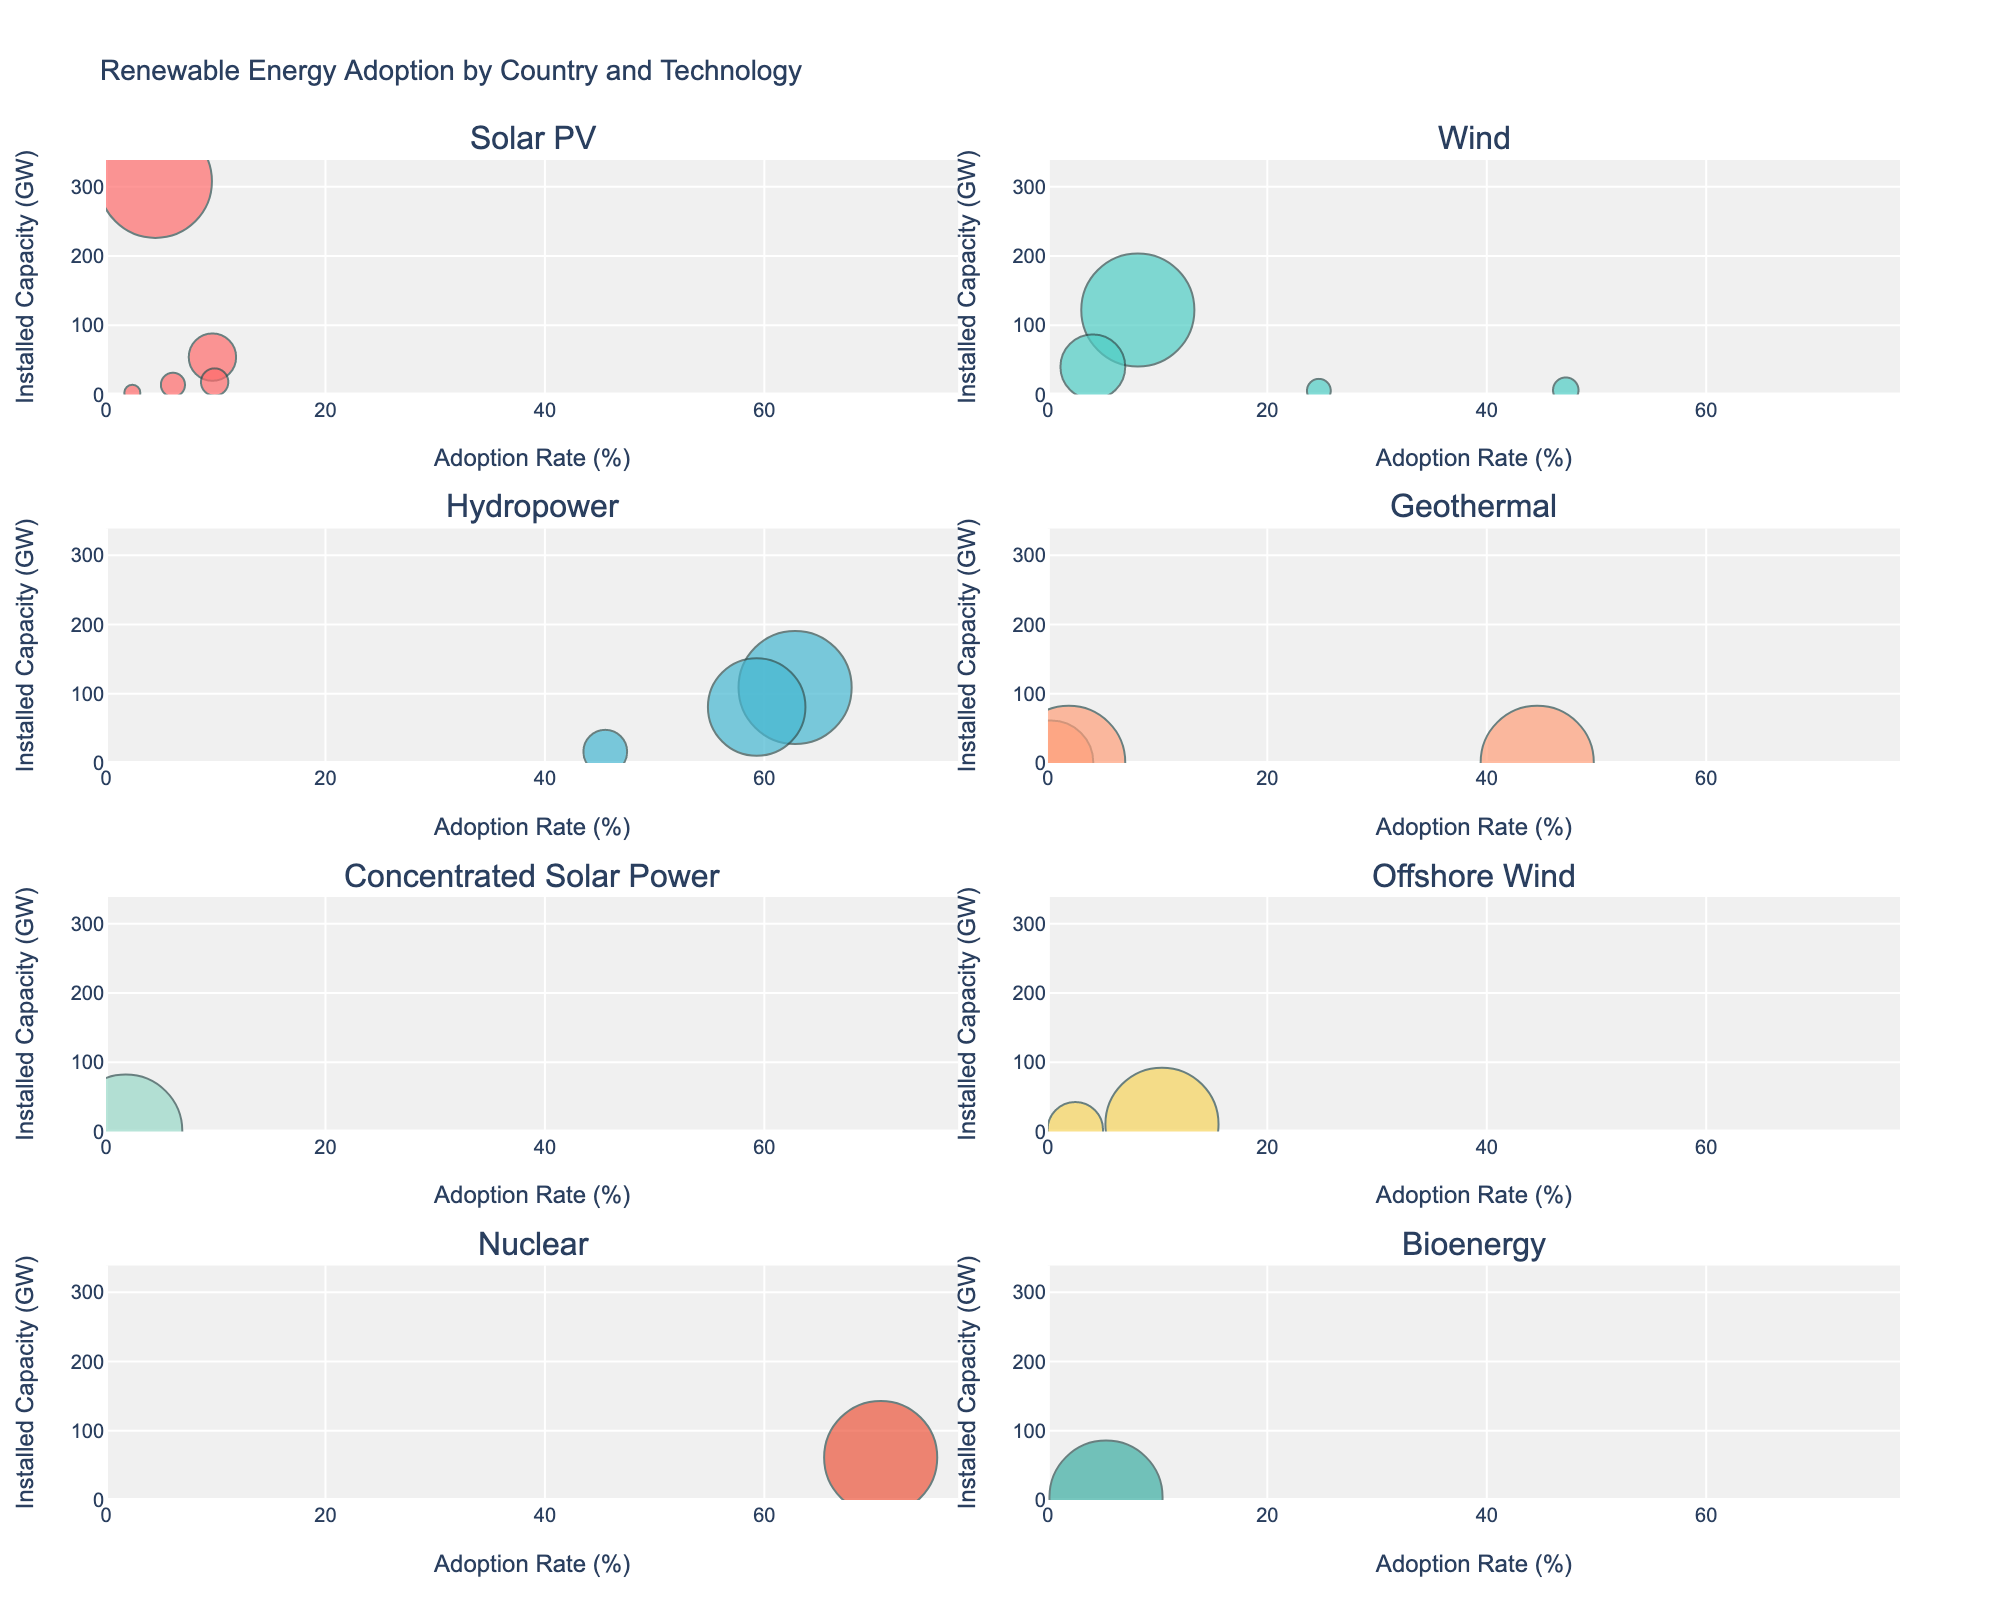Which technology type has the highest adoption rate? The adoption rate is displayed along the x-axis. By scanning the x-axis, we see that France's Nuclear technology has the highest value of 70.6%.
Answer: Nuclear What is the installed capacity of Solar PV in China? Find the bubble chart for Solar PV and locate the bubble representing China. The y-axis indicates the installed capacity, which is 308 GW for China.
Answer: 308 GW How many countries have an adoption rate higher than 40%? By observing the x-axes across different subplots, count the bubbles whose x-values exceed 40%. This occurs for Hydropower in Brazil and Canada, Wind in Denmark, and Geothermal in Kenya. In total, there are 4 countries.
Answer: 4 What is the total installed capacity of Wind energy in the displayed countries? Sum the installed capacity values for Wind energy across all relevant bubbles. The capacities are United States (122 GW), India (40 GW), Denmark (6.2 GW), and Portugal (5.4 GW), amounting to 122 + 40 + 6.2 + 5.4 = 173.6 GW.
Answer: 173.6 GW Which technology has the smallest installed capacity at its highest adoption rate? Compare the bubble charts, noting the highest adoption rate in each and the corresponding installed capacity. Japan's Geothermal technology has both the smallest highest adoption rate (0.3%) and the smallest installed capacity (0.5 GW).
Answer: Geothermal Which country has the highest installed capacity in Nuclear technology? Look at the Nuclear subplot and compare the y-values of the bubbles. France has the highest installed capacity at 61.4 GW.
Answer: France How does Brazil's adoption rate and installed capacity of Hydropower compare to Canada's? Locate the Hydropower subplot and compare the bubbles for Brazil and Canada. Brazil has an adoption rate of 62.8% and an installed capacity of 109 GW, whereas Canada has an adoption rate of 59.3% and an installed capacity of 81 GW. Brazil has a slightly higher adoption rate and a higher installed capacity than Canada.
Answer: Brazil > Canada What is the average adoption rate of Solar PV technology among listed countries? Identify the Solar PV subplot and average the adoption rates for China (4.5%), Germany (9.7%), Australia (9.9%), and Spain (6.1%). (4.5 + 9.7 + 9.9 + 6.1) / 4 = 30.2 / 4 = 7.55%
Answer: 7.55% For which technology does Kenya have an adoption rate close to that of Denmark's highest adoption rate technology? Compare the adoption rate in Kenya's Geothermal subplot (44.6%) to Denmark's Wind subplot (47.2%). The rates are very close, with Kenya's rate slightly lower.
Answer: Wind Which countries have the same adoption rate for Offshore Wind technology? In the Offshore Wind subplot, observe the adoption rates. The United Kingdom and the Netherlands both have an adoption rate of 10.4%.
Answer: United Kingdom and Netherlands 